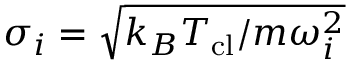Convert formula to latex. <formula><loc_0><loc_0><loc_500><loc_500>\sigma _ { i } = \sqrt { k _ { B } T _ { c l } / m \omega _ { i } ^ { 2 } }</formula> 